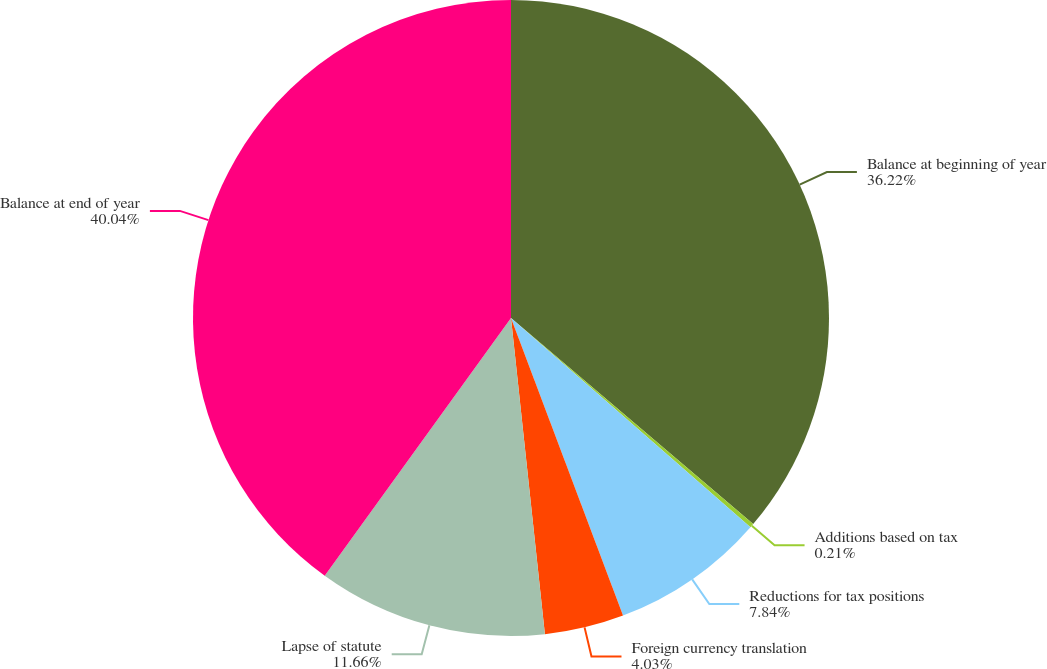<chart> <loc_0><loc_0><loc_500><loc_500><pie_chart><fcel>Balance at beginning of year<fcel>Additions based on tax<fcel>Reductions for tax positions<fcel>Foreign currency translation<fcel>Lapse of statute<fcel>Balance at end of year<nl><fcel>36.22%<fcel>0.21%<fcel>7.84%<fcel>4.03%<fcel>11.66%<fcel>40.04%<nl></chart> 